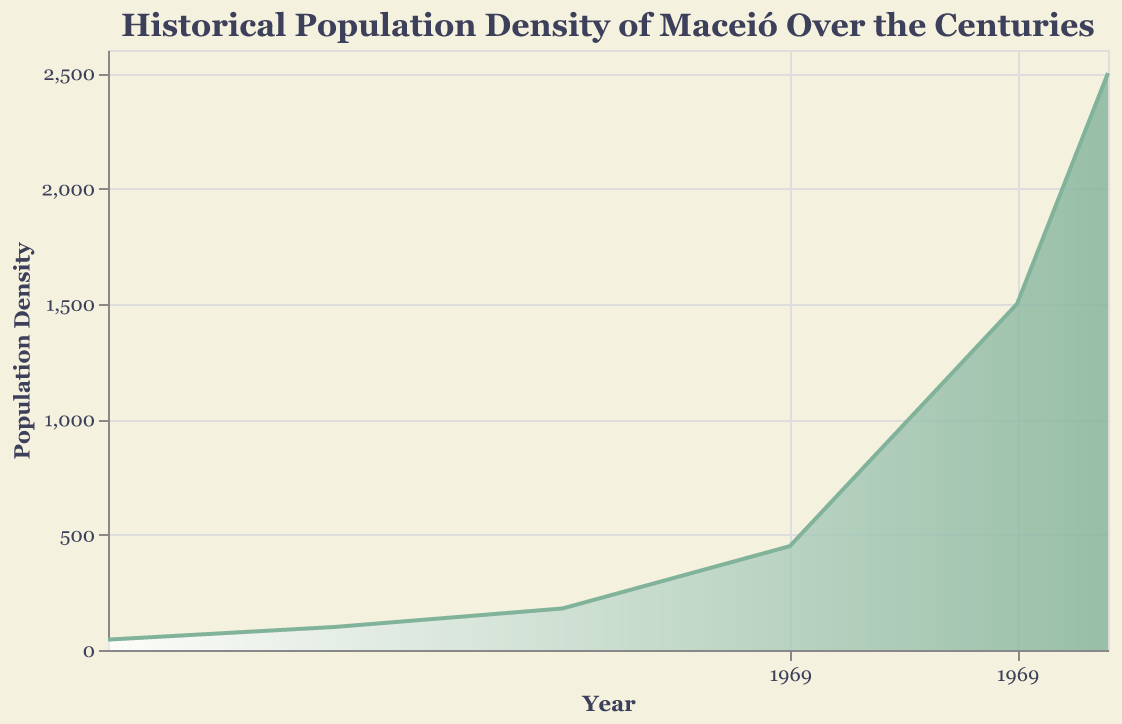what is the title of the plot? The title of the plot is located at the top and reads "Historical Population Density of Maceió Over the Centuries".
Answer: Historical Population Density of Maceió Over the Centuries How many years are represented on the plot? By counting the distinct data points along the x-axis, we see the years 1800, 1850, 1900, 1950, 2000, and 2020, totaling 6 years.
Answer: 6 years What was the population density in 1950? Referring to the specific point on the plot for the year 1950 on the x-axis, the population density is given as 450.
Answer: 450 What is the main color used in the plot area? The area is shaded with a gradient that starts with white and transitions to a shade of green.
Answer: Green How much has the population density increased from 2000 to 2020? The population density in 2000 was 1500 and in 2020 it was 2500. The increase is calculated as 2500 - 1500 = 1000.
Answer: 1000 Between which consecutive years did the population density show the largest increase? Checking the differences between consecutive years: 1850-1800 = 55, 1900-1850 = 80, 1950-1900 = 270, 2000-1950 = 1050, 2020-2000 = 1000. The largest increase is between 1950 and 2000 with an increase of 1050.
Answer: 1950 and 2000 Which year shows the smallest population density? The plot shows that the population density in 1800 is 45, which is the smallest value among the given years.
Answer: 1800 By what factor did the population density increase from 1800 to 1950? The population density increased from 45 in 1800 to 450 in 1950. The factor of increase is calculated as 450 / 45 = 10.
Answer: 10 What trend can you observe in the population density over the centuries? The plot indicates that the population density has overall increased significantly over time, particularly showing rapid growth between 1950 and 2000.
Answer: Increasing How does the slope of the line change between different periods? The slope of the line is gentle with slow increases from 1800 to 1900, steepens intently between 1950 and 2000, and remains steep into 2020, indicating rapid population growth during these latter periods.
Answer: The slope steepens over time 